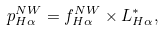<formula> <loc_0><loc_0><loc_500><loc_500>p _ { H \alpha } ^ { N W } = f _ { H \alpha } ^ { N W } \times L _ { H \alpha } ^ { * } ,</formula> 